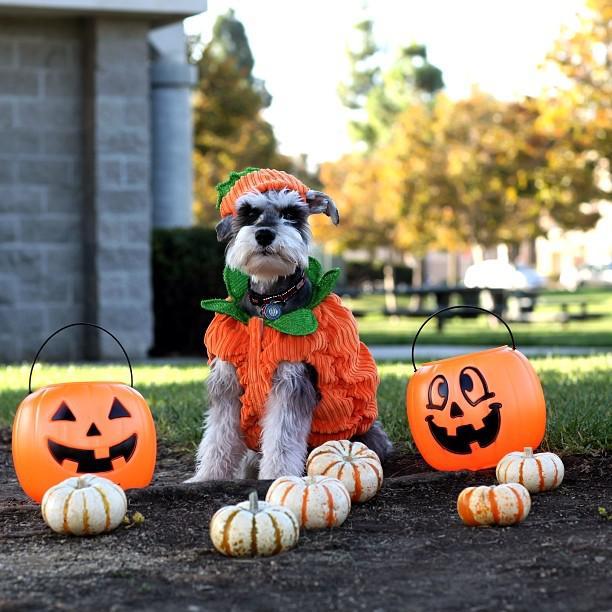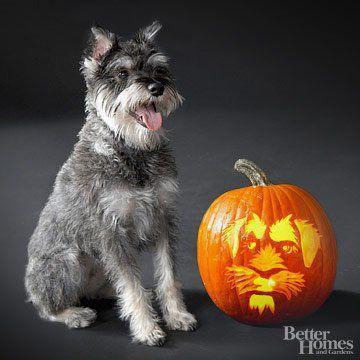The first image is the image on the left, the second image is the image on the right. Considering the images on both sides, is "At least one schnauzer is sitting upright and wearing a collar with a dangling tag, but no other attire." valid? Answer yes or no. No. The first image is the image on the left, the second image is the image on the right. Examine the images to the left and right. Is the description "One dog has its mouth open." accurate? Answer yes or no. Yes. 